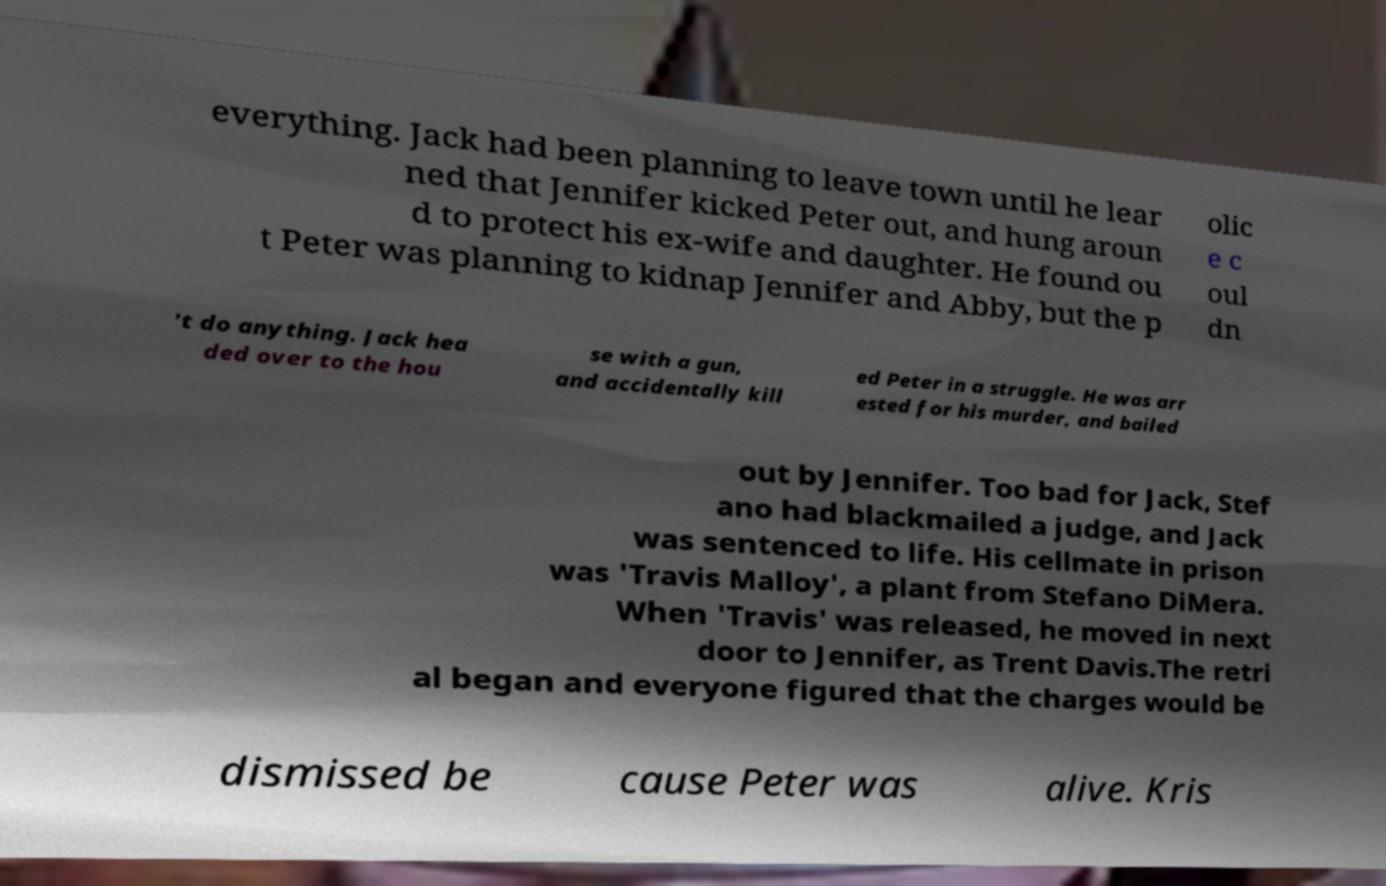Please read and relay the text visible in this image. What does it say? everything. Jack had been planning to leave town until he lear ned that Jennifer kicked Peter out, and hung aroun d to protect his ex-wife and daughter. He found ou t Peter was planning to kidnap Jennifer and Abby, but the p olic e c oul dn 't do anything. Jack hea ded over to the hou se with a gun, and accidentally kill ed Peter in a struggle. He was arr ested for his murder, and bailed out by Jennifer. Too bad for Jack, Stef ano had blackmailed a judge, and Jack was sentenced to life. His cellmate in prison was 'Travis Malloy', a plant from Stefano DiMera. When 'Travis' was released, he moved in next door to Jennifer, as Trent Davis.The retri al began and everyone figured that the charges would be dismissed be cause Peter was alive. Kris 